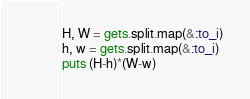Convert code to text. <code><loc_0><loc_0><loc_500><loc_500><_Ruby_>H, W = gets.split.map(&:to_i)
h, w = gets.split.map(&:to_i)
puts (H-h)*(W-w)
</code> 